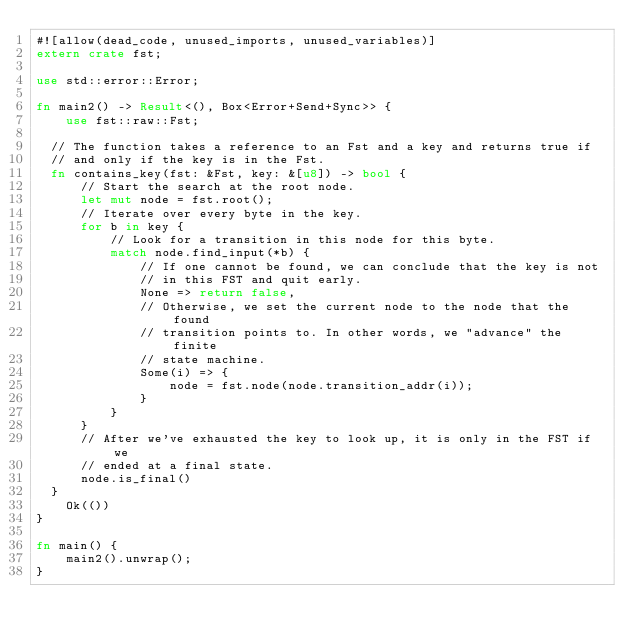Convert code to text. <code><loc_0><loc_0><loc_500><loc_500><_Rust_>#![allow(dead_code, unused_imports, unused_variables)]
extern crate fst;

use std::error::Error;

fn main2() -> Result<(), Box<Error+Send+Sync>> {
    use fst::raw::Fst;
  
  // The function takes a reference to an Fst and a key and returns true if
  // and only if the key is in the Fst.
  fn contains_key(fst: &Fst, key: &[u8]) -> bool {
      // Start the search at the root node.
      let mut node = fst.root();
      // Iterate over every byte in the key.
      for b in key {
          // Look for a transition in this node for this byte.
          match node.find_input(*b) {
              // If one cannot be found, we can conclude that the key is not
              // in this FST and quit early.
              None => return false,
              // Otherwise, we set the current node to the node that the found
              // transition points to. In other words, we "advance" the finite
              // state machine.
              Some(i) => {
                  node = fst.node(node.transition_addr(i));
              }
          }
      }
      // After we've exhausted the key to look up, it is only in the FST if we
      // ended at a final state.
      node.is_final()
  }
    Ok(())
}

fn main() {
    main2().unwrap();
}
</code> 